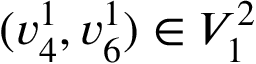<formula> <loc_0><loc_0><loc_500><loc_500>( v _ { 4 } ^ { 1 } , v _ { 6 } ^ { 1 } ) \in V _ { 1 } ^ { 2 }</formula> 